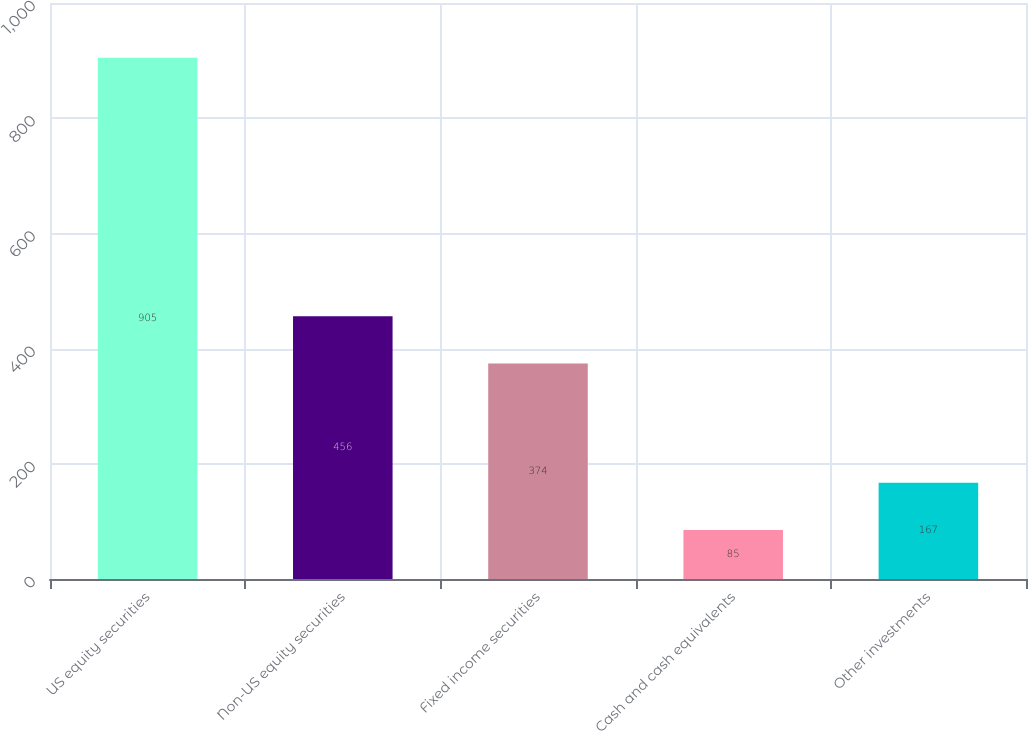<chart> <loc_0><loc_0><loc_500><loc_500><bar_chart><fcel>US equity securities<fcel>Non-US equity securities<fcel>Fixed income securities<fcel>Cash and cash equivalents<fcel>Other investments<nl><fcel>905<fcel>456<fcel>374<fcel>85<fcel>167<nl></chart> 